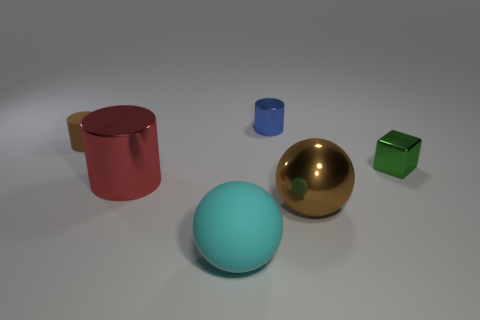Subtract all small cylinders. How many cylinders are left? 1 Subtract 1 balls. How many balls are left? 1 Add 2 tiny objects. How many objects exist? 8 Subtract all brown balls. How many balls are left? 1 Subtract all cubes. How many objects are left? 5 Subtract 0 yellow balls. How many objects are left? 6 Subtract all blue cylinders. Subtract all blue blocks. How many cylinders are left? 2 Subtract all small cyan metal spheres. Subtract all brown cylinders. How many objects are left? 5 Add 2 tiny metallic cylinders. How many tiny metallic cylinders are left? 3 Add 3 small metallic balls. How many small metallic balls exist? 3 